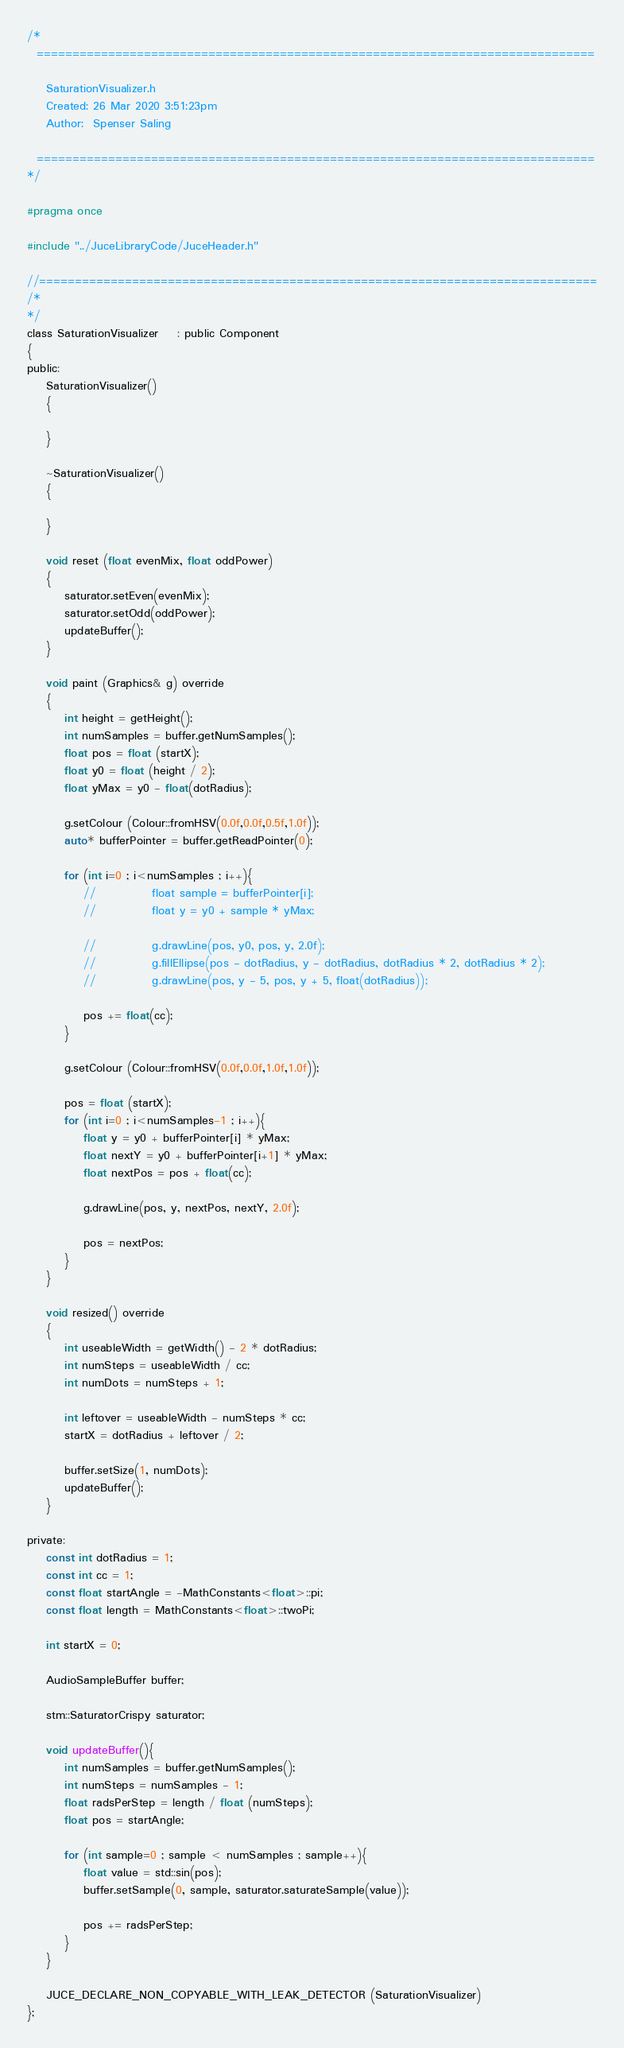Convert code to text. <code><loc_0><loc_0><loc_500><loc_500><_C_>/*
  ==============================================================================

    SaturationVisualizer.h
    Created: 26 Mar 2020 3:51:23pm
    Author:  Spenser Saling

  ==============================================================================
*/

#pragma once

#include "../JuceLibraryCode/JuceHeader.h"

//==============================================================================
/*
*/
class SaturationVisualizer    : public Component
{
public:
    SaturationVisualizer()
    {
        
    }

    ~SaturationVisualizer()
    {
        
    }
    
    void reset (float evenMix, float oddPower)
    {
        saturator.setEven(evenMix);
        saturator.setOdd(oddPower);
        updateBuffer();
    }

    void paint (Graphics& g) override
    {
        int height = getHeight();
        int numSamples = buffer.getNumSamples();
        float pos = float (startX);
        float y0 = float (height / 2);
        float yMax = y0 - float(dotRadius);
        
        g.setColour (Colour::fromHSV(0.0f,0.0f,0.5f,1.0f));
        auto* bufferPointer = buffer.getReadPointer(0);
        
        for (int i=0 ; i<numSamples ; i++){
            //            float sample = bufferPointer[i];
            //            float y = y0 + sample * yMax;
            
            //            g.drawLine(pos, y0, pos, y, 2.0f);
            //            g.fillEllipse(pos - dotRadius, y - dotRadius, dotRadius * 2, dotRadius * 2);
            //            g.drawLine(pos, y - 5, pos, y + 5, float(dotRadius));
            
            pos += float(cc);
        }
        
        g.setColour (Colour::fromHSV(0.0f,0.0f,1.0f,1.0f));
        
        pos = float (startX);
        for (int i=0 ; i<numSamples-1 ; i++){
            float y = y0 + bufferPointer[i] * yMax;
            float nextY = y0 + bufferPointer[i+1] * yMax;
            float nextPos = pos + float(cc);
            
            g.drawLine(pos, y, nextPos, nextY, 2.0f);
            
            pos = nextPos;
        }
    }

    void resized() override
    {
        int useableWidth = getWidth() - 2 * dotRadius;
        int numSteps = useableWidth / cc;
        int numDots = numSteps + 1;
        
        int leftover = useableWidth - numSteps * cc;
        startX = dotRadius + leftover / 2;
        
        buffer.setSize(1, numDots);
        updateBuffer();
    }

private:
    const int dotRadius = 1;
    const int cc = 1;
    const float startAngle = -MathConstants<float>::pi;
    const float length = MathConstants<float>::twoPi;
    
    int startX = 0;
    
    AudioSampleBuffer buffer;
    
    stm::SaturatorCrispy saturator;
    
    void updateBuffer(){
        int numSamples = buffer.getNumSamples();
        int numSteps = numSamples - 1;
        float radsPerStep = length / float (numSteps);
        float pos = startAngle;
        
        for (int sample=0 ; sample < numSamples ; sample++){
            float value = std::sin(pos);
            buffer.setSample(0, sample, saturator.saturateSample(value));
            
            pos += radsPerStep;
        }
    }
    
    JUCE_DECLARE_NON_COPYABLE_WITH_LEAK_DETECTOR (SaturationVisualizer)
};

</code> 